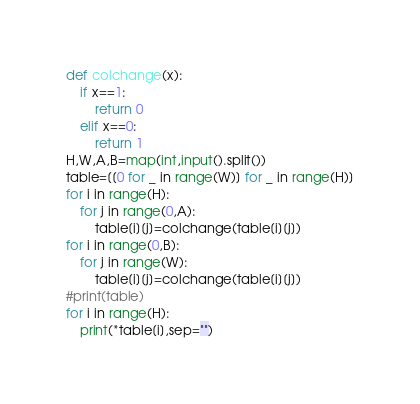Convert code to text. <code><loc_0><loc_0><loc_500><loc_500><_Python_>def colchange(x):
    if x==1:
        return 0
    elif x==0:
        return 1
H,W,A,B=map(int,input().split())
table=[[0 for _ in range(W)] for _ in range(H)]
for i in range(H):
    for j in range(0,A):
        table[i][j]=colchange(table[i][j])
for i in range(0,B):
    for j in range(W):
        table[i][j]=colchange(table[i][j])
#print(table)
for i in range(H):
    print(*table[i],sep="")
</code> 